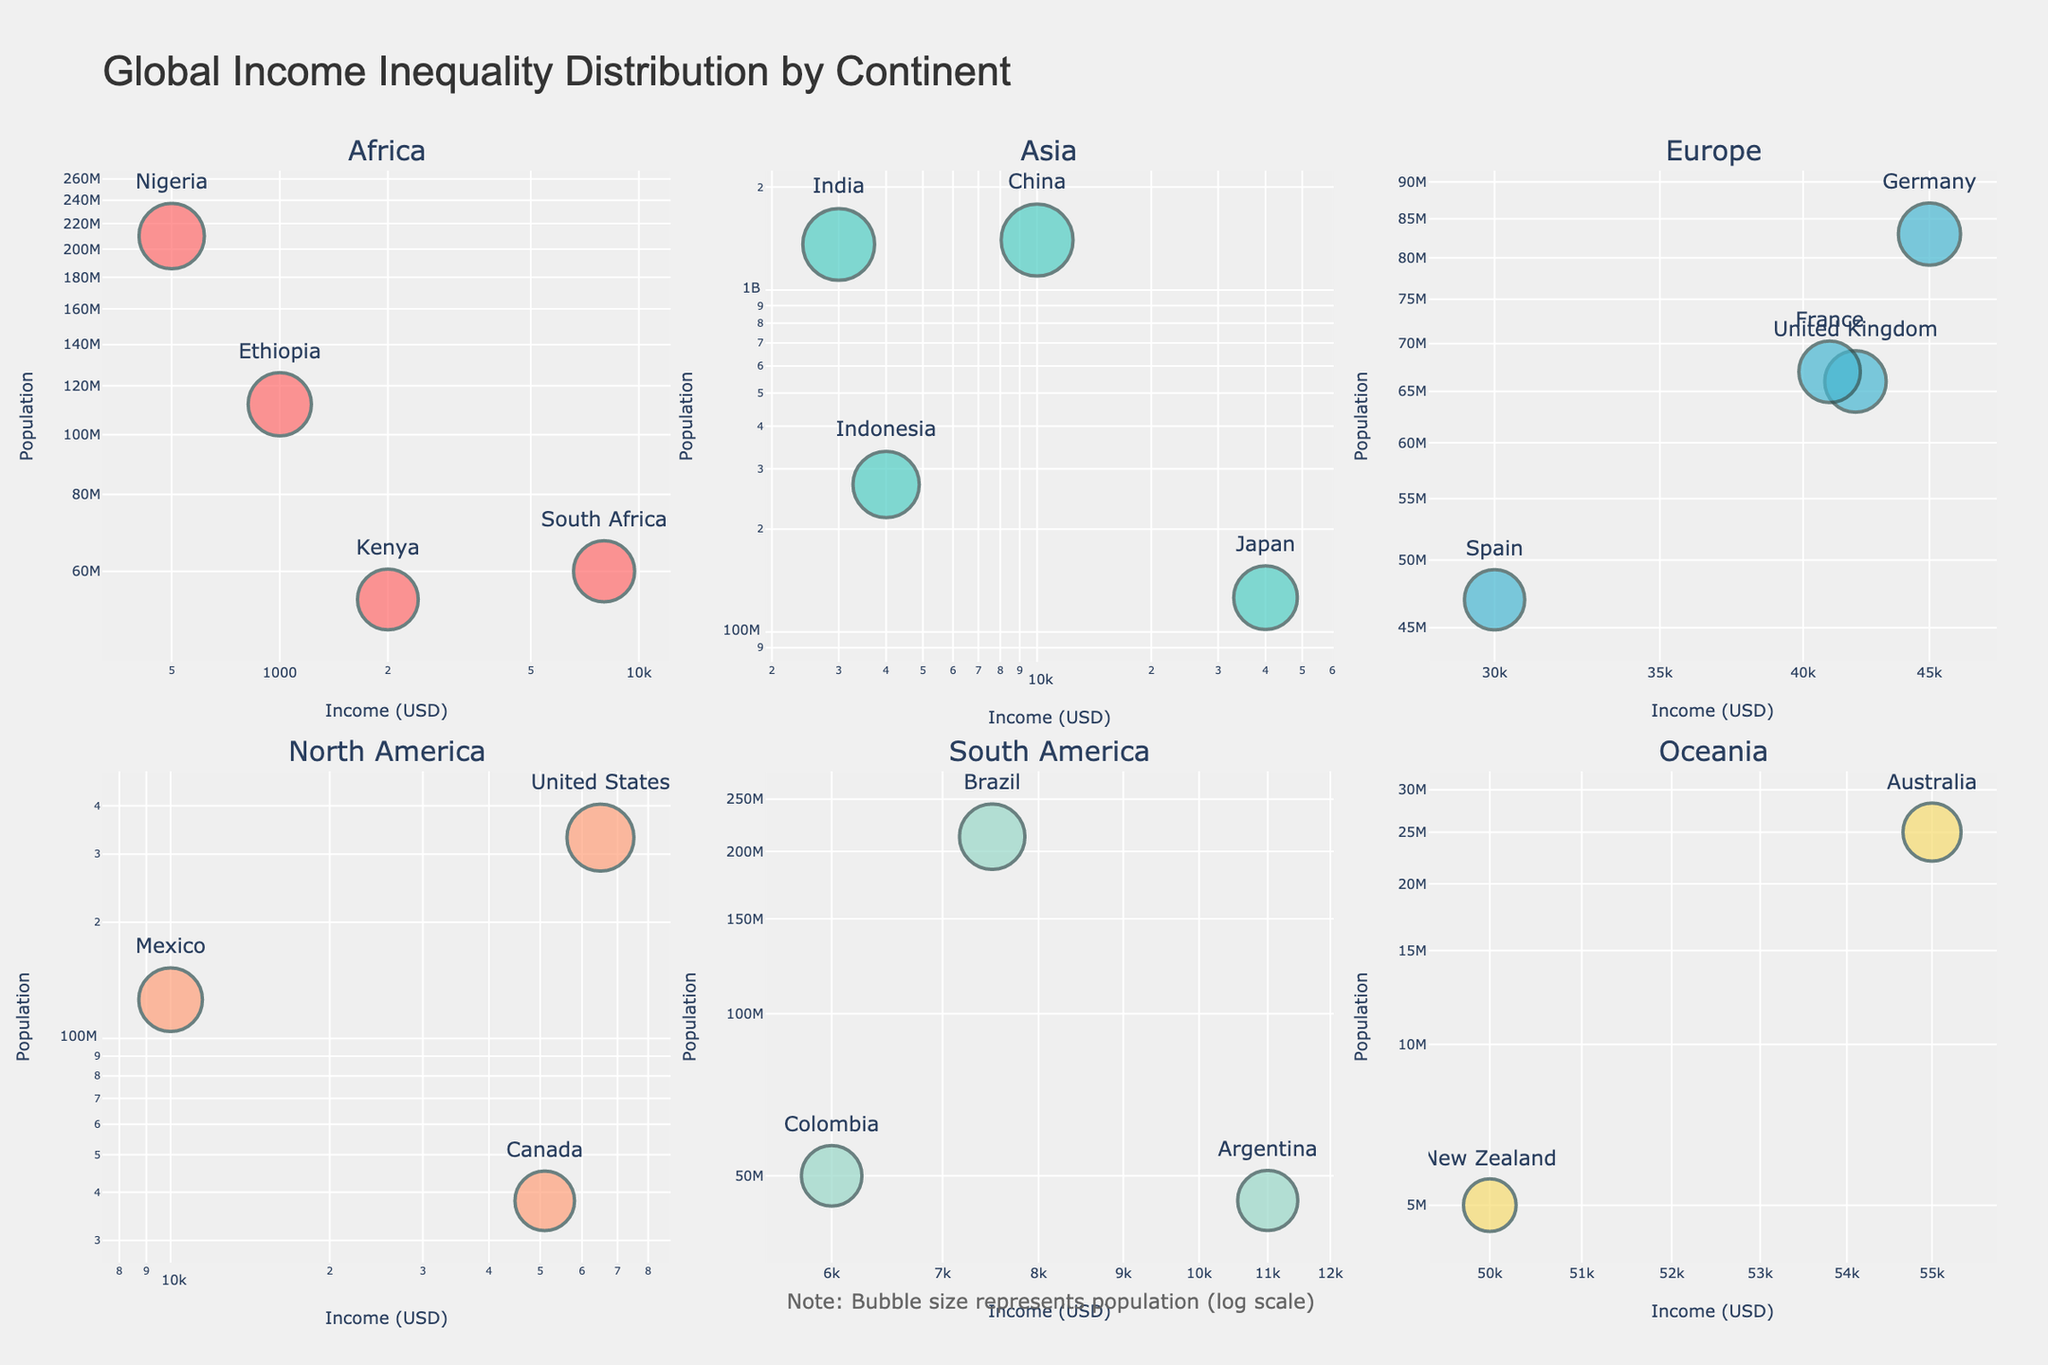Which continent has the country with the highest income shown in the figure? The figure shows that North America has the country with the highest income, as the United States has an income of $65,000.
Answer: North America What is the title of the figure? The title is displayed at the top of the figure and reads "Global Income Inequality Distribution by Continent".
Answer: Global Income Inequality Distribution by Continent How many continents are represented in the figure? The figure contains subplots for each continent, which are titled individually. Counting these titles, we see Africa, Asia, Europe, North America, South America, and Oceania.
Answer: 6 Which country in the figure has the smallest population and what continent is it in? Examining the scatter plots, New Zealand has the smallest population of 5,000,000, and it is in Oceania.
Answer: New Zealand, Oceania What is the primary color used to represent African countries in the figure? The color used for the African countries' markers is red.
Answer: Red Which continent shows the most significant variation in incomes among its countries? Looking at the income ranges across continents in the subplots, Asia shows the most significant variation, with incomes ranging from India's $3,000 to Japan's $40,000.
Answer: Asia If you compare the incomes of countries in Europe, which country has the highest income? In the European subplot, Germany has the highest income, which is $45,000.
Answer: Germany What is the bubble size indicative of in the figure? The note below the subplots mentions that bubble size is indicative of the population (log scale).
Answer: Population Which country has the lowest income in South America? In the South America subplot, Colombia has the lowest income of $6,000.
Answer: Colombia Are the income levels in the figure displayed using a linear or logarithmic scale? Checking the x-axes of all subplots, they all use a logarithmic scale for income levels (USD).
Answer: Logarithmic scale 